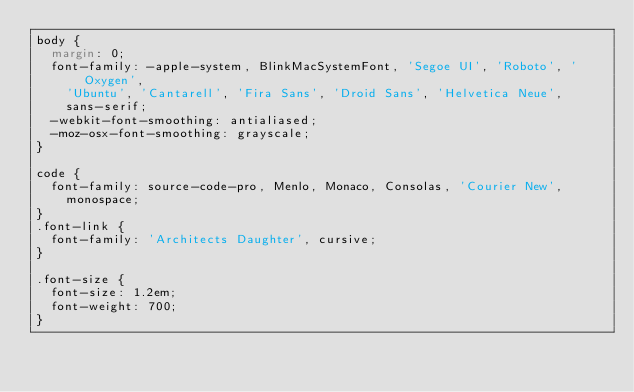Convert code to text. <code><loc_0><loc_0><loc_500><loc_500><_CSS_>body {
  margin: 0;
  font-family: -apple-system, BlinkMacSystemFont, 'Segoe UI', 'Roboto', 'Oxygen',
    'Ubuntu', 'Cantarell', 'Fira Sans', 'Droid Sans', 'Helvetica Neue',
    sans-serif;
  -webkit-font-smoothing: antialiased;
  -moz-osx-font-smoothing: grayscale;
}

code {
  font-family: source-code-pro, Menlo, Monaco, Consolas, 'Courier New',
    monospace;
}
.font-link {
  font-family: 'Architects Daughter', cursive;
}

.font-size {
  font-size: 1.2em;
  font-weight: 700;
}
</code> 